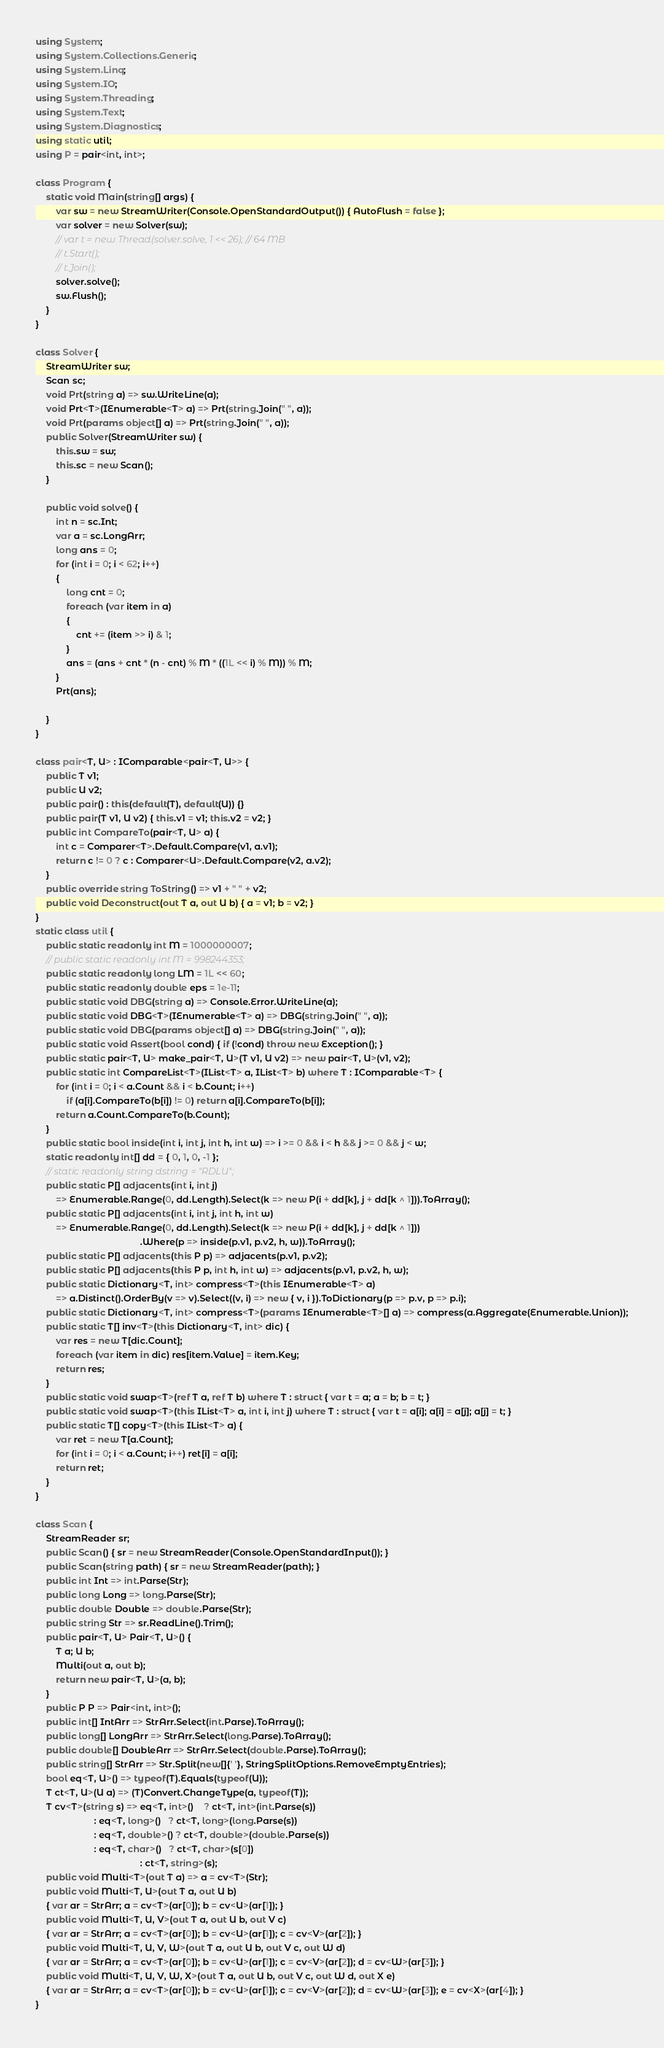<code> <loc_0><loc_0><loc_500><loc_500><_C#_>using System;
using System.Collections.Generic;
using System.Linq;
using System.IO;
using System.Threading;
using System.Text;
using System.Diagnostics;
using static util;
using P = pair<int, int>;

class Program {
    static void Main(string[] args) {
        var sw = new StreamWriter(Console.OpenStandardOutput()) { AutoFlush = false };
        var solver = new Solver(sw);
        // var t = new Thread(solver.solve, 1 << 26); // 64 MB
        // t.Start();
        // t.Join();
        solver.solve();
        sw.Flush();
    }
}

class Solver {
    StreamWriter sw;
    Scan sc;
    void Prt(string a) => sw.WriteLine(a);
    void Prt<T>(IEnumerable<T> a) => Prt(string.Join(" ", a));
    void Prt(params object[] a) => Prt(string.Join(" ", a));
    public Solver(StreamWriter sw) {
        this.sw = sw;
        this.sc = new Scan();
    }

    public void solve() {
        int n = sc.Int;
        var a = sc.LongArr;
        long ans = 0;
        for (int i = 0; i < 62; i++)
        {
            long cnt = 0;
            foreach (var item in a)
            {
                cnt += (item >> i) & 1;
            }
            ans = (ans + cnt * (n - cnt) % M * ((1L << i) % M)) % M;
        }
        Prt(ans);

    }
}

class pair<T, U> : IComparable<pair<T, U>> {
    public T v1;
    public U v2;
    public pair() : this(default(T), default(U)) {}
    public pair(T v1, U v2) { this.v1 = v1; this.v2 = v2; }
    public int CompareTo(pair<T, U> a) {
        int c = Comparer<T>.Default.Compare(v1, a.v1);
        return c != 0 ? c : Comparer<U>.Default.Compare(v2, a.v2);
    }
    public override string ToString() => v1 + " " + v2;
    public void Deconstruct(out T a, out U b) { a = v1; b = v2; }
}
static class util {
    public static readonly int M = 1000000007;
    // public static readonly int M = 998244353;
    public static readonly long LM = 1L << 60;
    public static readonly double eps = 1e-11;
    public static void DBG(string a) => Console.Error.WriteLine(a);
    public static void DBG<T>(IEnumerable<T> a) => DBG(string.Join(" ", a));
    public static void DBG(params object[] a) => DBG(string.Join(" ", a));
    public static void Assert(bool cond) { if (!cond) throw new Exception(); }
    public static pair<T, U> make_pair<T, U>(T v1, U v2) => new pair<T, U>(v1, v2);
    public static int CompareList<T>(IList<T> a, IList<T> b) where T : IComparable<T> {
        for (int i = 0; i < a.Count && i < b.Count; i++)
            if (a[i].CompareTo(b[i]) != 0) return a[i].CompareTo(b[i]);
        return a.Count.CompareTo(b.Count);
    }
    public static bool inside(int i, int j, int h, int w) => i >= 0 && i < h && j >= 0 && j < w;
    static readonly int[] dd = { 0, 1, 0, -1 };
    // static readonly string dstring = "RDLU";
    public static P[] adjacents(int i, int j)
        => Enumerable.Range(0, dd.Length).Select(k => new P(i + dd[k], j + dd[k ^ 1])).ToArray();
    public static P[] adjacents(int i, int j, int h, int w)
        => Enumerable.Range(0, dd.Length).Select(k => new P(i + dd[k], j + dd[k ^ 1]))
                                         .Where(p => inside(p.v1, p.v2, h, w)).ToArray();
    public static P[] adjacents(this P p) => adjacents(p.v1, p.v2);
    public static P[] adjacents(this P p, int h, int w) => adjacents(p.v1, p.v2, h, w);
    public static Dictionary<T, int> compress<T>(this IEnumerable<T> a)
        => a.Distinct().OrderBy(v => v).Select((v, i) => new { v, i }).ToDictionary(p => p.v, p => p.i);
    public static Dictionary<T, int> compress<T>(params IEnumerable<T>[] a) => compress(a.Aggregate(Enumerable.Union));
    public static T[] inv<T>(this Dictionary<T, int> dic) {
        var res = new T[dic.Count];
        foreach (var item in dic) res[item.Value] = item.Key;
        return res;
    }
    public static void swap<T>(ref T a, ref T b) where T : struct { var t = a; a = b; b = t; }
    public static void swap<T>(this IList<T> a, int i, int j) where T : struct { var t = a[i]; a[i] = a[j]; a[j] = t; }
    public static T[] copy<T>(this IList<T> a) {
        var ret = new T[a.Count];
        for (int i = 0; i < a.Count; i++) ret[i] = a[i];
        return ret;
    }
}

class Scan {
    StreamReader sr;
    public Scan() { sr = new StreamReader(Console.OpenStandardInput()); }
    public Scan(string path) { sr = new StreamReader(path); }
    public int Int => int.Parse(Str);
    public long Long => long.Parse(Str);
    public double Double => double.Parse(Str);
    public string Str => sr.ReadLine().Trim();
    public pair<T, U> Pair<T, U>() {
        T a; U b;
        Multi(out a, out b);
        return new pair<T, U>(a, b);
    }
    public P P => Pair<int, int>();
    public int[] IntArr => StrArr.Select(int.Parse).ToArray();
    public long[] LongArr => StrArr.Select(long.Parse).ToArray();
    public double[] DoubleArr => StrArr.Select(double.Parse).ToArray();
    public string[] StrArr => Str.Split(new[]{' '}, StringSplitOptions.RemoveEmptyEntries);
    bool eq<T, U>() => typeof(T).Equals(typeof(U));
    T ct<T, U>(U a) => (T)Convert.ChangeType(a, typeof(T));
    T cv<T>(string s) => eq<T, int>()    ? ct<T, int>(int.Parse(s))
                       : eq<T, long>()   ? ct<T, long>(long.Parse(s))
                       : eq<T, double>() ? ct<T, double>(double.Parse(s))
                       : eq<T, char>()   ? ct<T, char>(s[0])
                                         : ct<T, string>(s);
    public void Multi<T>(out T a) => a = cv<T>(Str);
    public void Multi<T, U>(out T a, out U b)
    { var ar = StrArr; a = cv<T>(ar[0]); b = cv<U>(ar[1]); }
    public void Multi<T, U, V>(out T a, out U b, out V c)
    { var ar = StrArr; a = cv<T>(ar[0]); b = cv<U>(ar[1]); c = cv<V>(ar[2]); }
    public void Multi<T, U, V, W>(out T a, out U b, out V c, out W d)
    { var ar = StrArr; a = cv<T>(ar[0]); b = cv<U>(ar[1]); c = cv<V>(ar[2]); d = cv<W>(ar[3]); }
    public void Multi<T, U, V, W, X>(out T a, out U b, out V c, out W d, out X e)
    { var ar = StrArr; a = cv<T>(ar[0]); b = cv<U>(ar[1]); c = cv<V>(ar[2]); d = cv<W>(ar[3]); e = cv<X>(ar[4]); }
}
</code> 